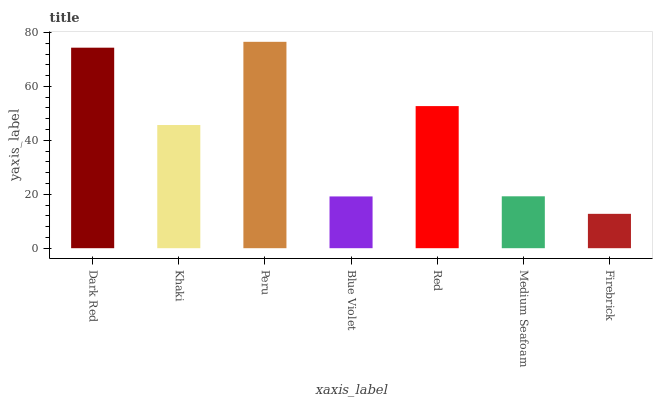Is Khaki the minimum?
Answer yes or no. No. Is Khaki the maximum?
Answer yes or no. No. Is Dark Red greater than Khaki?
Answer yes or no. Yes. Is Khaki less than Dark Red?
Answer yes or no. Yes. Is Khaki greater than Dark Red?
Answer yes or no. No. Is Dark Red less than Khaki?
Answer yes or no. No. Is Khaki the high median?
Answer yes or no. Yes. Is Khaki the low median?
Answer yes or no. Yes. Is Blue Violet the high median?
Answer yes or no. No. Is Blue Violet the low median?
Answer yes or no. No. 